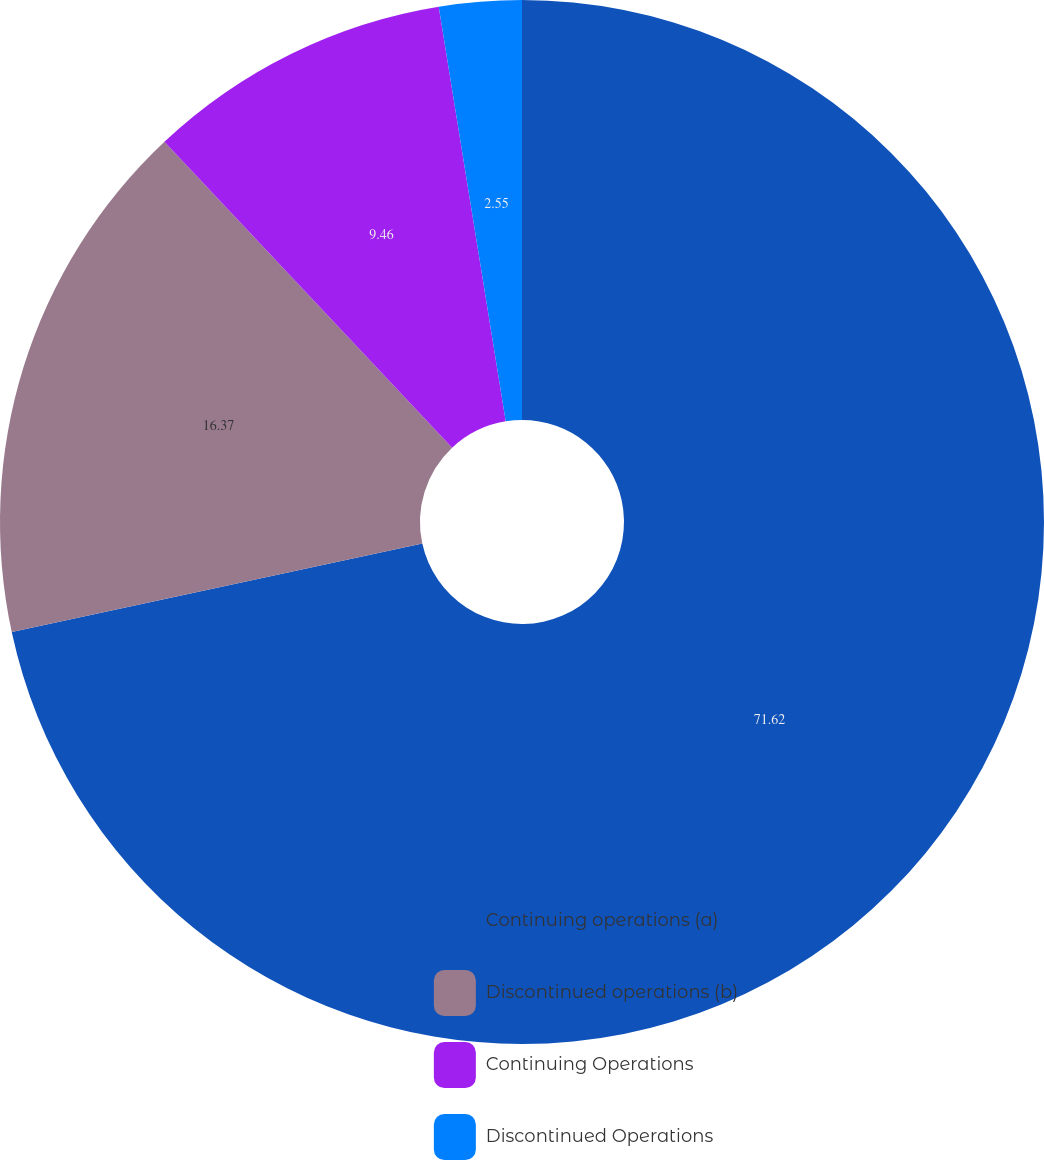Convert chart to OTSL. <chart><loc_0><loc_0><loc_500><loc_500><pie_chart><fcel>Continuing operations (a)<fcel>Discontinued operations (b)<fcel>Continuing Operations<fcel>Discontinued Operations<nl><fcel>71.62%<fcel>16.37%<fcel>9.46%<fcel>2.55%<nl></chart> 